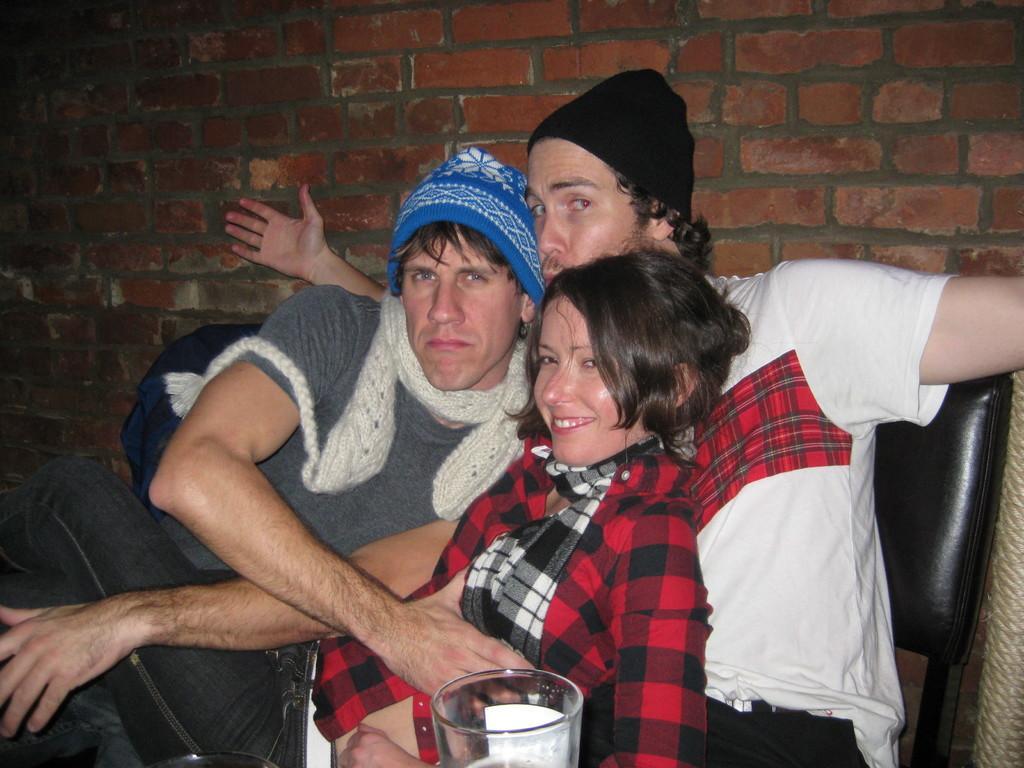Describe this image in one or two sentences. In this image there are group of persons sitting and smiling. In the front there is glass. In the background there is wall which is red in colour. 